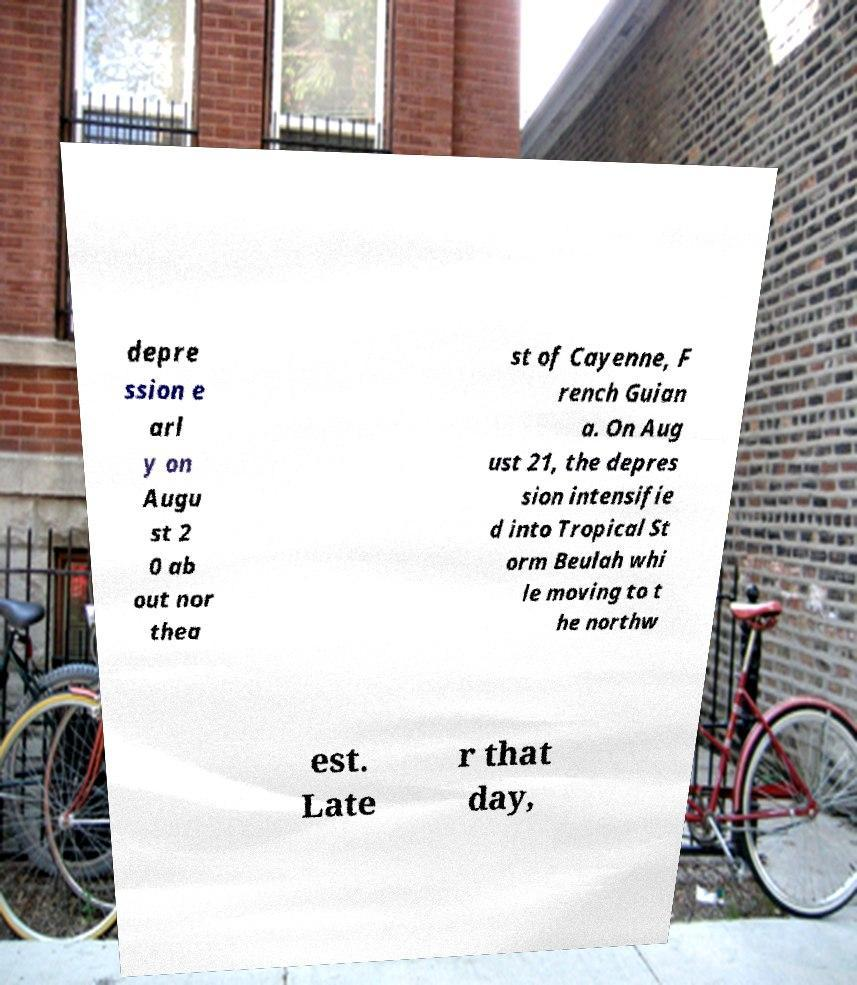There's text embedded in this image that I need extracted. Can you transcribe it verbatim? depre ssion e arl y on Augu st 2 0 ab out nor thea st of Cayenne, F rench Guian a. On Aug ust 21, the depres sion intensifie d into Tropical St orm Beulah whi le moving to t he northw est. Late r that day, 